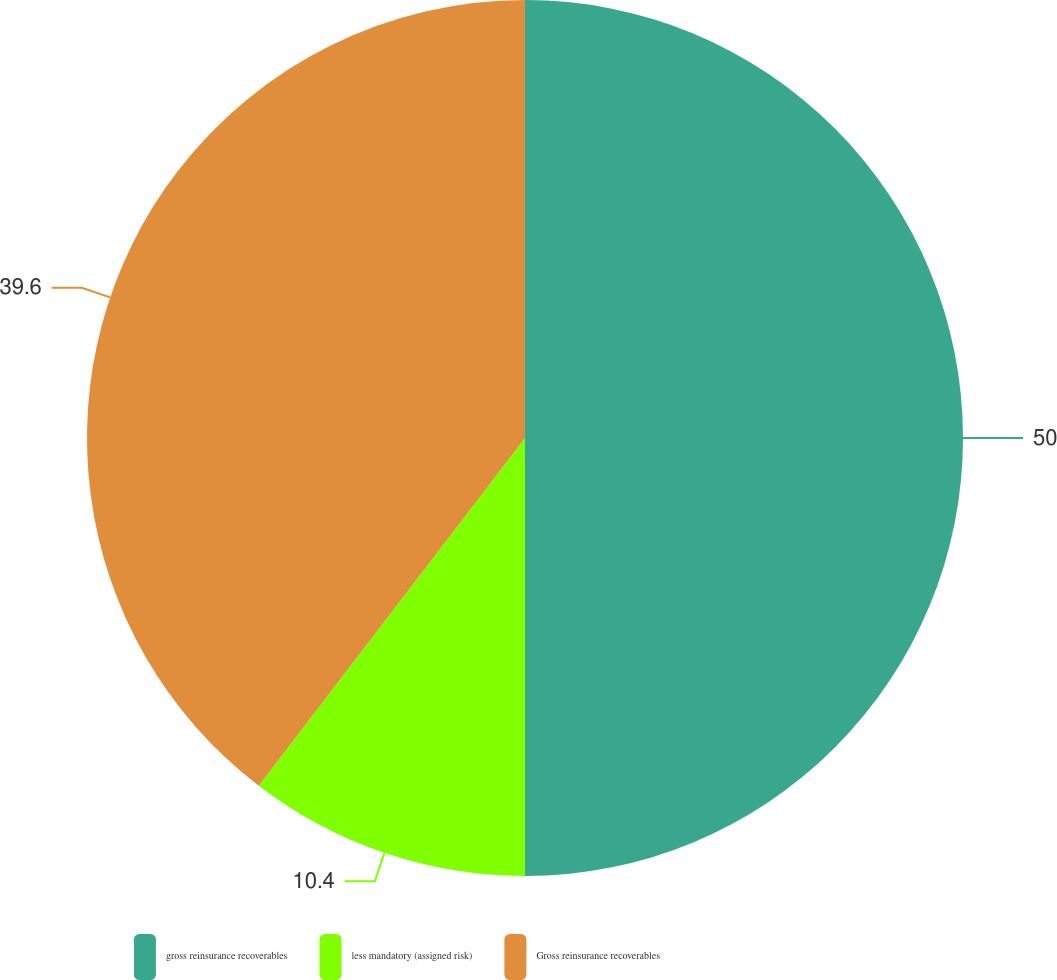Convert chart to OTSL. <chart><loc_0><loc_0><loc_500><loc_500><pie_chart><fcel>gross reinsurance recoverables<fcel>less mandatory (assigned risk)<fcel>Gross reinsurance recoverables<nl><fcel>50.0%<fcel>10.4%<fcel>39.6%<nl></chart> 